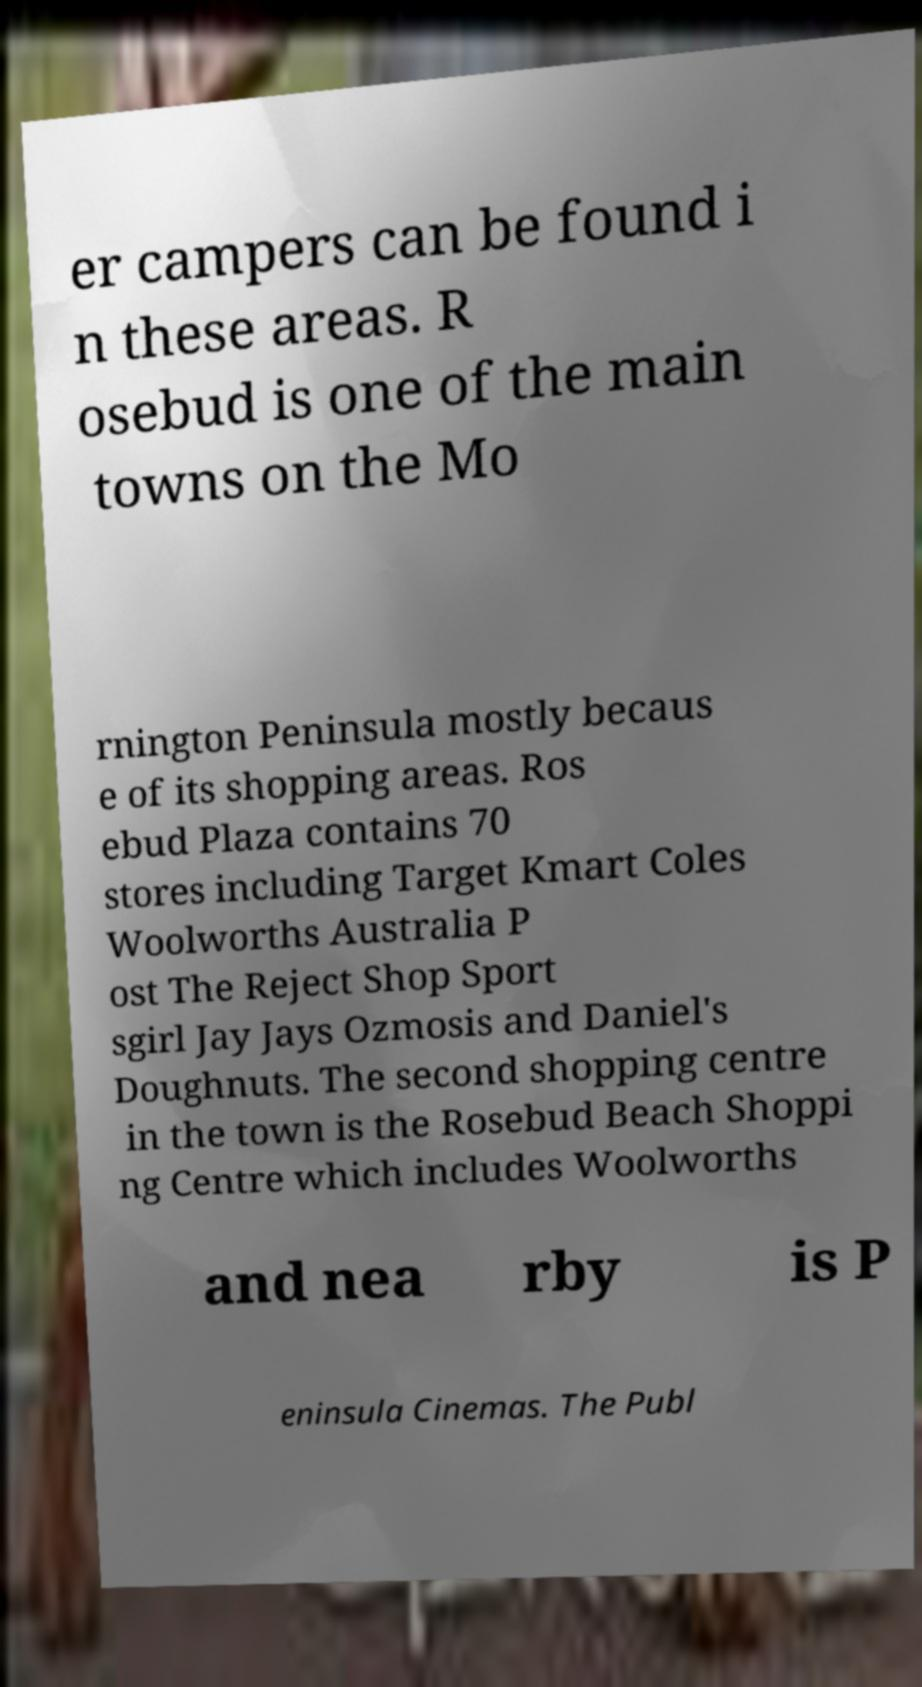I need the written content from this picture converted into text. Can you do that? er campers can be found i n these areas. R osebud is one of the main towns on the Mo rnington Peninsula mostly becaus e of its shopping areas. Ros ebud Plaza contains 70 stores including Target Kmart Coles Woolworths Australia P ost The Reject Shop Sport sgirl Jay Jays Ozmosis and Daniel's Doughnuts. The second shopping centre in the town is the Rosebud Beach Shoppi ng Centre which includes Woolworths and nea rby is P eninsula Cinemas. The Publ 